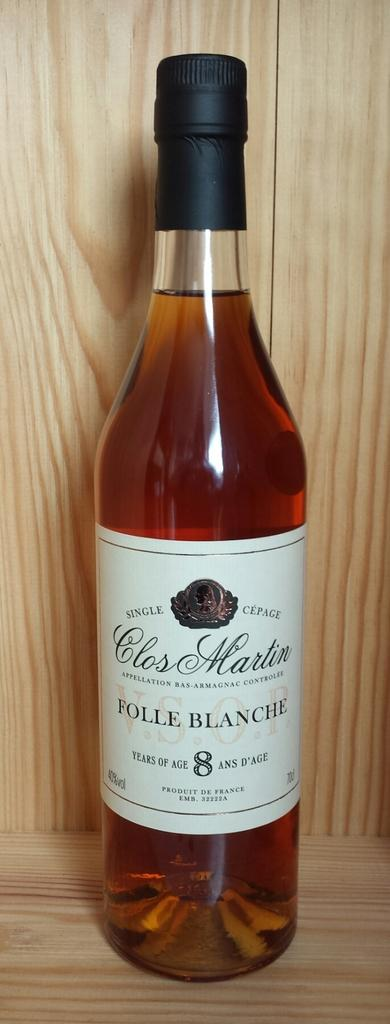<image>
Offer a succinct explanation of the picture presented. A bottle of single cepage Folle Blanche on a wooden surface. 